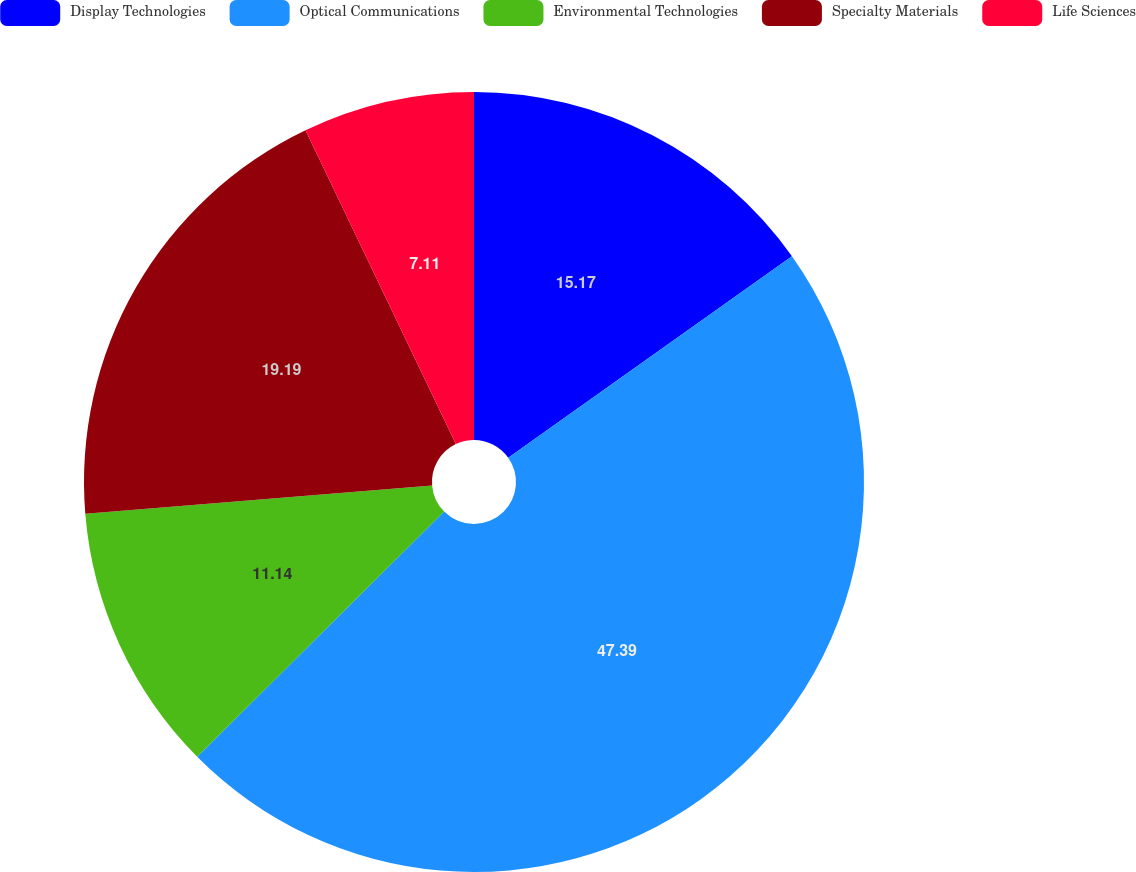Convert chart. <chart><loc_0><loc_0><loc_500><loc_500><pie_chart><fcel>Display Technologies<fcel>Optical Communications<fcel>Environmental Technologies<fcel>Specialty Materials<fcel>Life Sciences<nl><fcel>15.17%<fcel>47.39%<fcel>11.14%<fcel>19.19%<fcel>7.11%<nl></chart> 